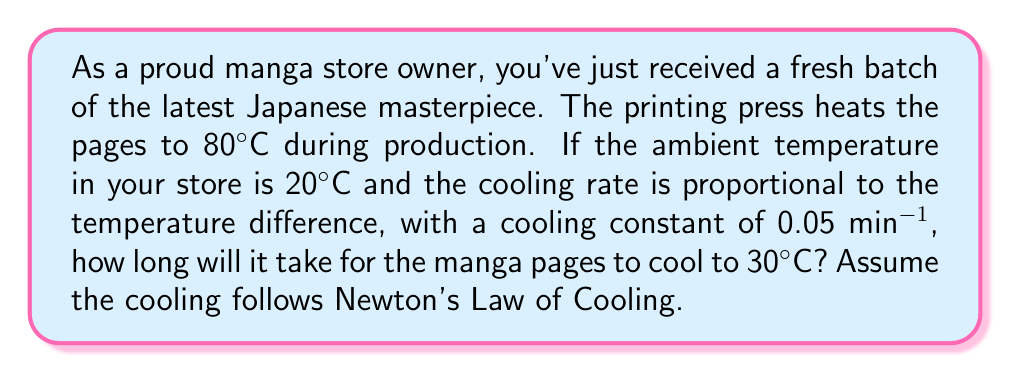Solve this math problem. Let's approach this step-by-step using Newton's Law of Cooling:

1) The general form of Newton's Law of Cooling is:

   $$\frac{dT}{dt} = -k(T - T_a)$$

   where $T$ is the temperature of the object, $T_a$ is the ambient temperature, $t$ is time, and $k$ is the cooling constant.

2) Integrating this equation gives us:

   $$T(t) = T_a + (T_0 - T_a)e^{-kt}$$

   where $T_0$ is the initial temperature.

3) Given information:
   - $T_0 = 80°C$ (initial temperature)
   - $T_a = 20°C$ (ambient temperature)
   - $k = 0.05$ min⁻¹ (cooling constant)
   - $T(t) = 30°C$ (final temperature we're solving for)

4) Substituting these values into our equation:

   $$30 = 20 + (80 - 20)e^{-0.05t}$$

5) Simplify:

   $$10 = 60e^{-0.05t}$$

6) Divide both sides by 60:

   $$\frac{1}{6} = e^{-0.05t}$$

7) Take the natural log of both sides:

   $$\ln(\frac{1}{6}) = -0.05t$$

8) Solve for $t$:

   $$t = -\frac{\ln(\frac{1}{6})}{0.05} \approx 35.67$$

Therefore, it will take approximately 35.67 minutes for the manga pages to cool to 30°C.
Answer: 35.67 minutes 